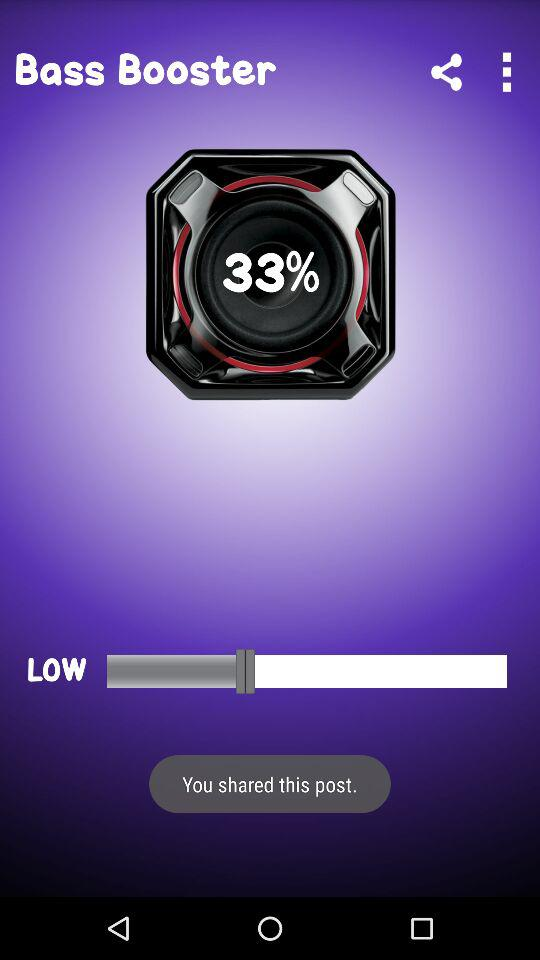What is the percentage of volume? The percentage of volume is 33. 